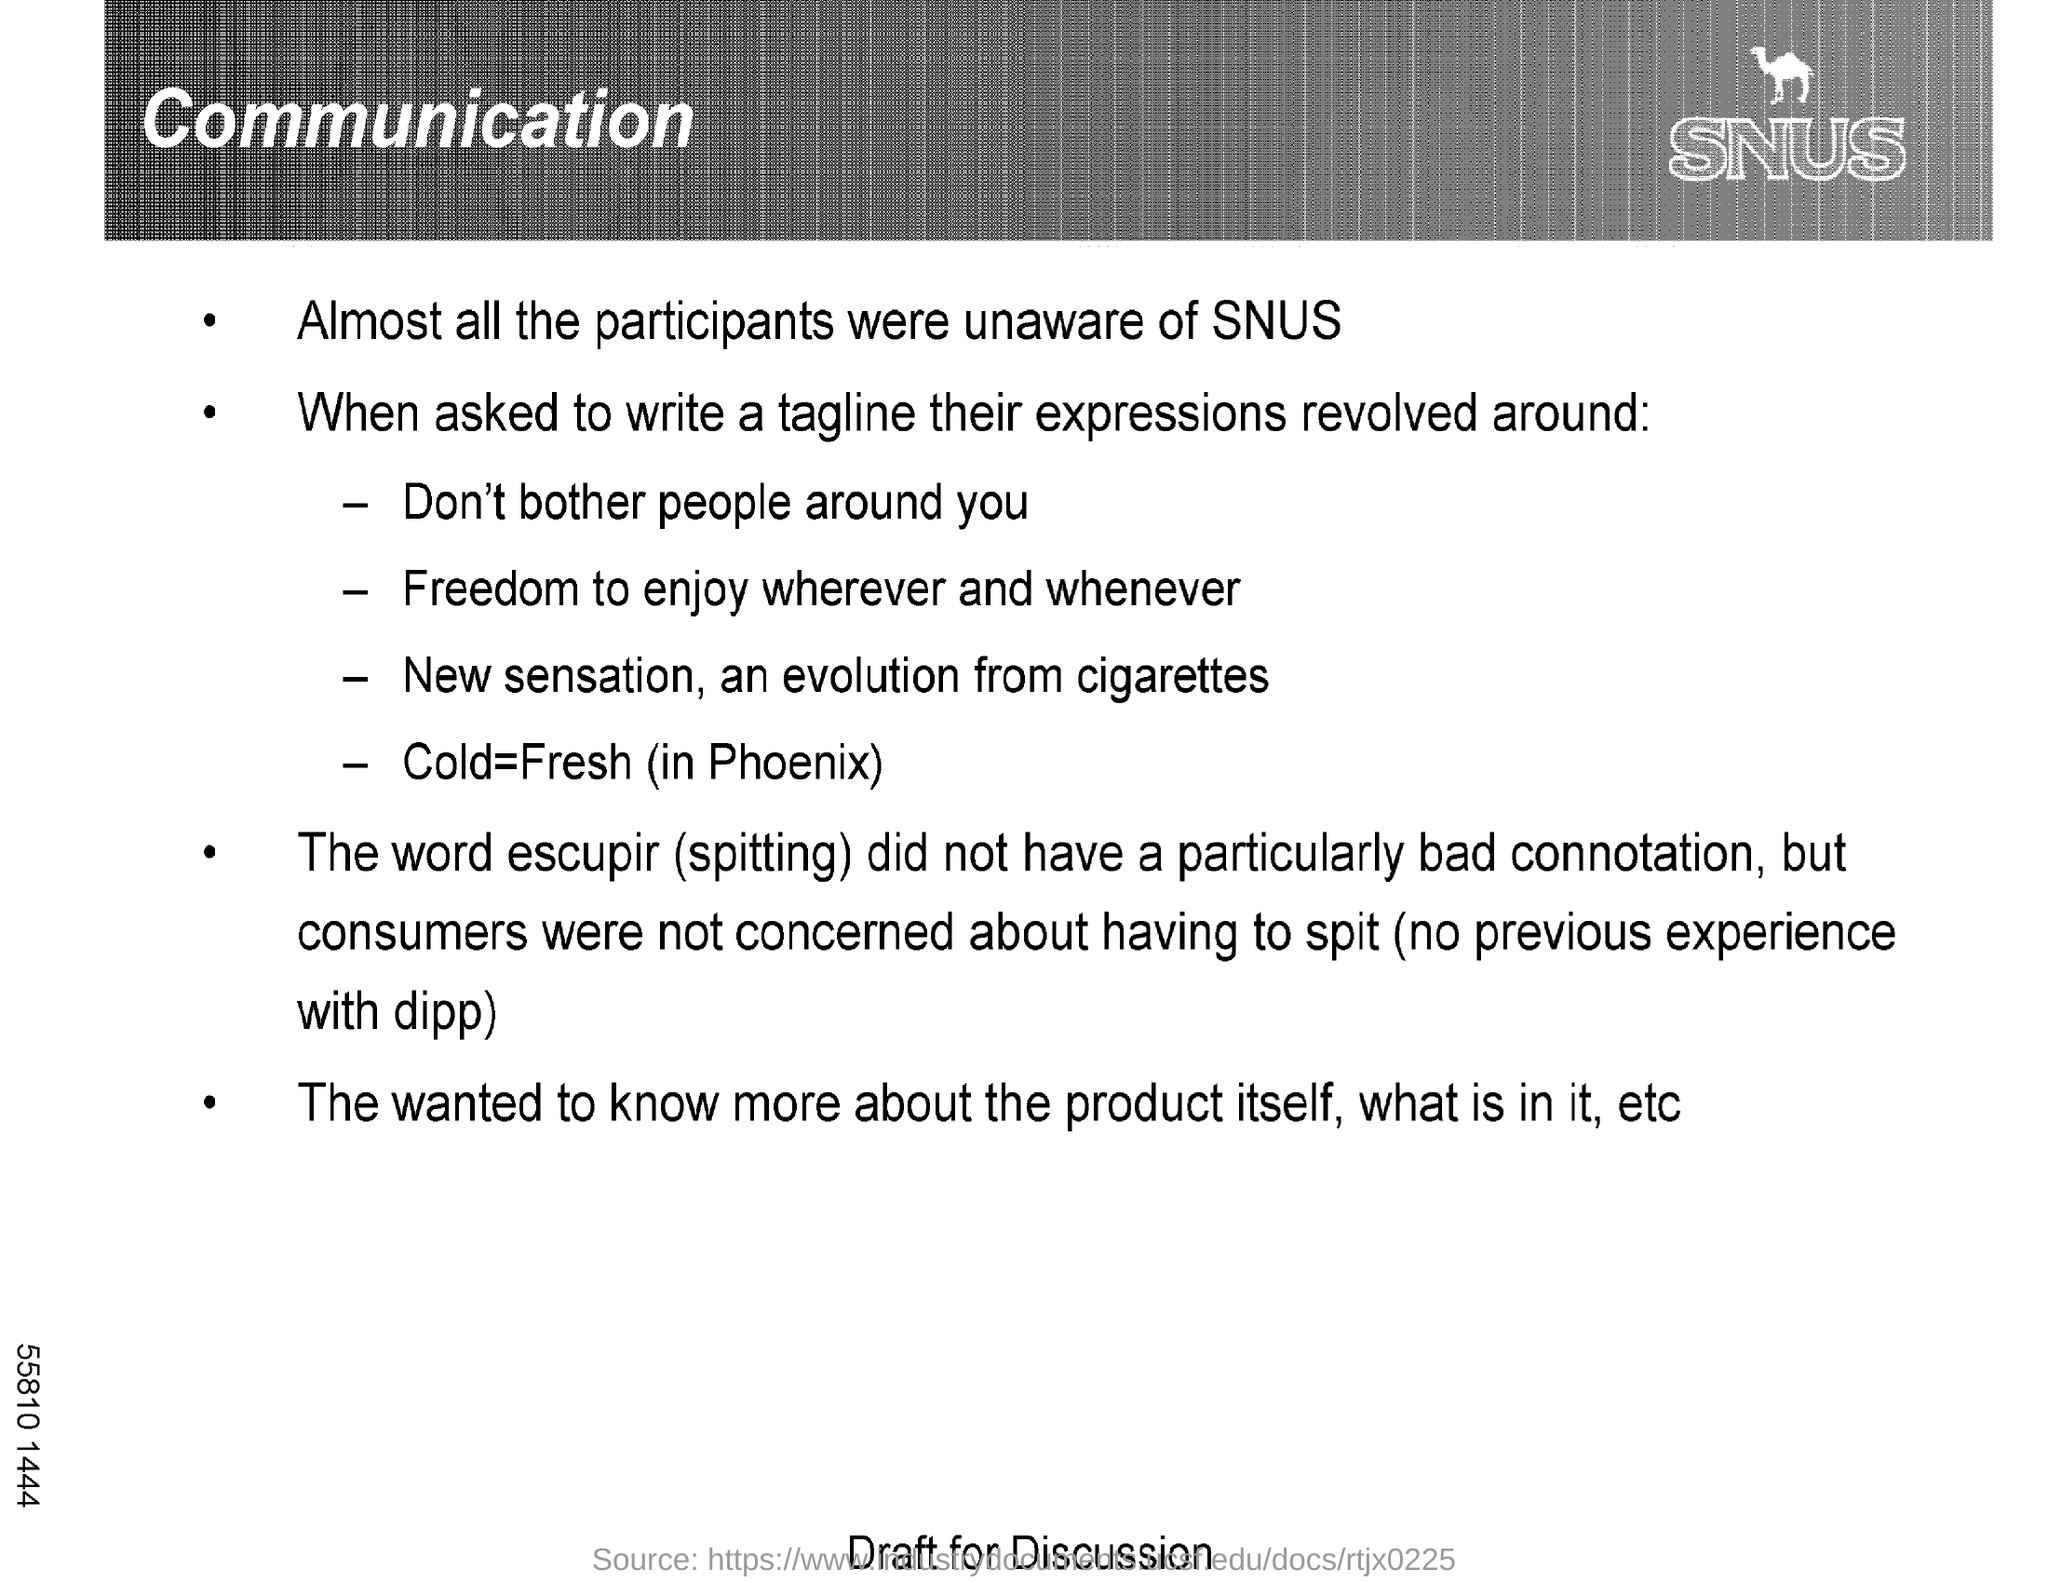Mention the first Tagline from the document?
Offer a very short reply. Don't bother people around you. What does the word Escupir mean?
Give a very brief answer. Spitting. 